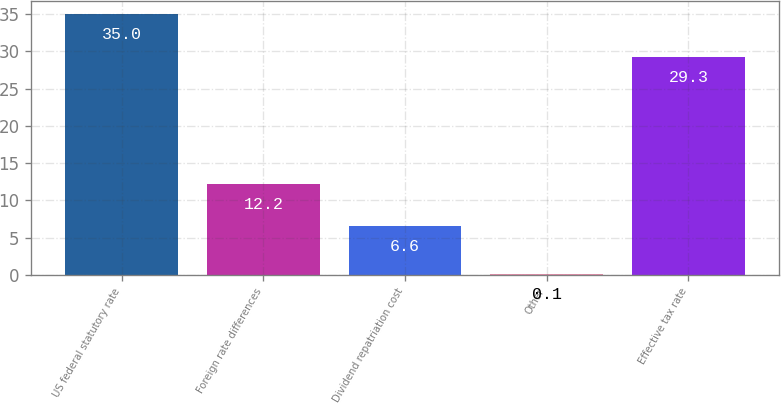Convert chart. <chart><loc_0><loc_0><loc_500><loc_500><bar_chart><fcel>US federal statutory rate<fcel>Foreign rate differences<fcel>Dividend repatriation cost<fcel>Other<fcel>Effective tax rate<nl><fcel>35<fcel>12.2<fcel>6.6<fcel>0.1<fcel>29.3<nl></chart> 